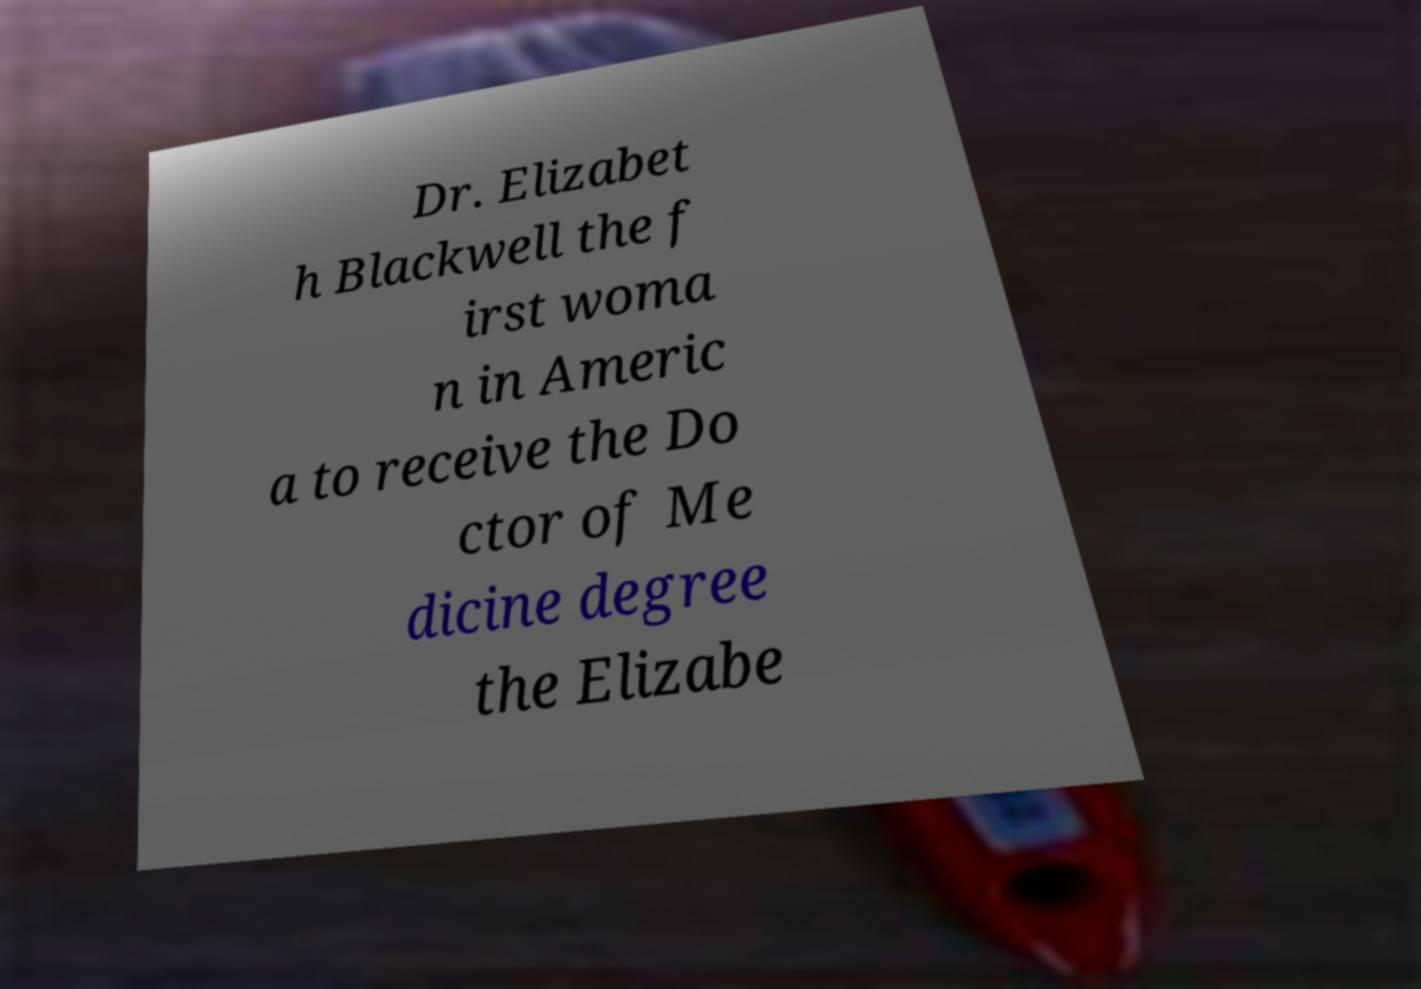Could you assist in decoding the text presented in this image and type it out clearly? Dr. Elizabet h Blackwell the f irst woma n in Americ a to receive the Do ctor of Me dicine degree the Elizabe 